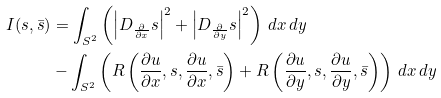Convert formula to latex. <formula><loc_0><loc_0><loc_500><loc_500>I ( s , \bar { s } ) & = \int _ { S ^ { 2 } } \left ( \left | D _ { \frac { \partial } { \partial x } } s \right | ^ { 2 } + \left | D _ { \frac { \partial } { \partial y } } s \right | ^ { 2 } \right ) \, d x \, d y \\ & - \int _ { S ^ { 2 } } \left ( R \left ( \frac { \partial u } { \partial x } , s , \frac { \partial u } { \partial x } , \bar { s } \right ) + R \left ( \frac { \partial u } { \partial y } , s , \frac { \partial u } { \partial y } , \bar { s } \right ) \right ) \, d x \, d y</formula> 